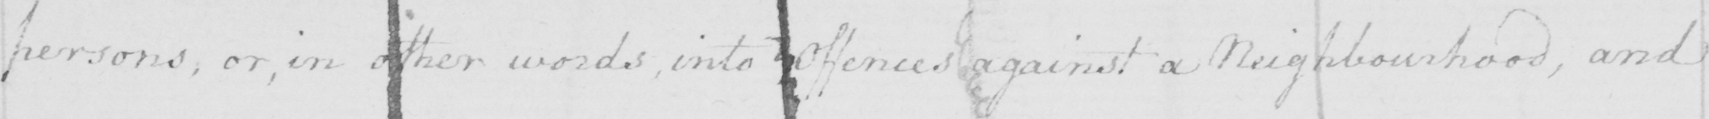Please provide the text content of this handwritten line. persons , or , in other words , into offences against a Neighborhood , and 